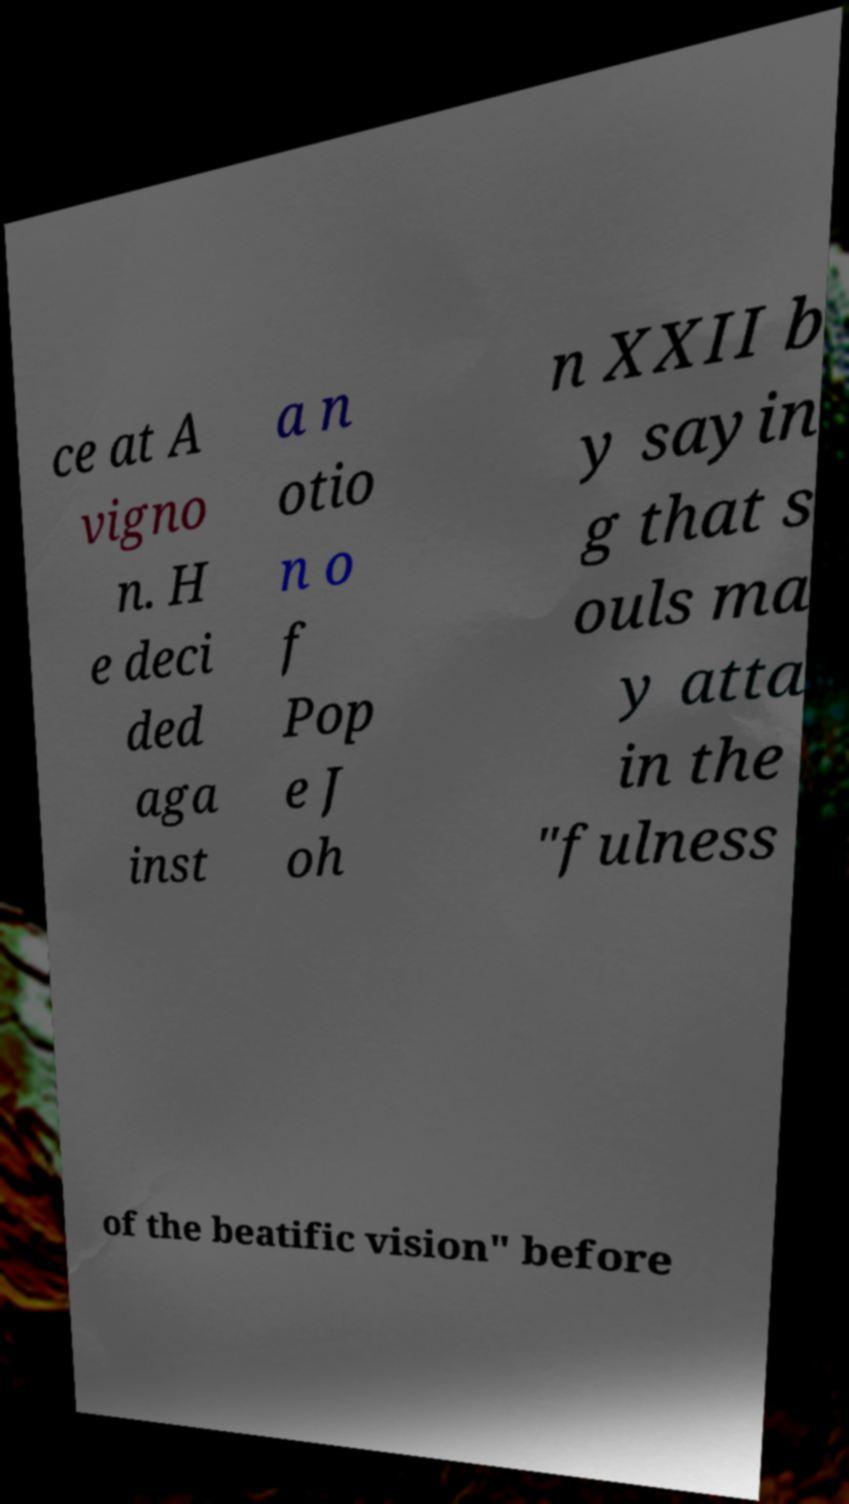Please identify and transcribe the text found in this image. ce at A vigno n. H e deci ded aga inst a n otio n o f Pop e J oh n XXII b y sayin g that s ouls ma y atta in the "fulness of the beatific vision" before 